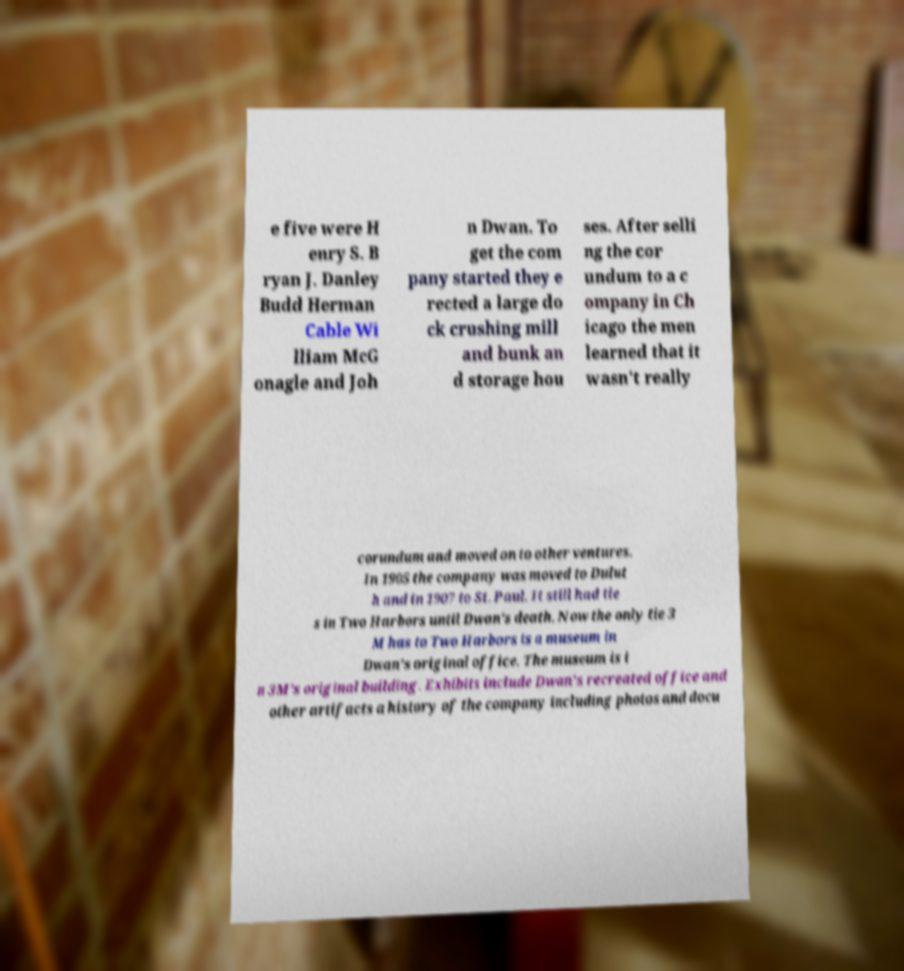Could you extract and type out the text from this image? e five were H enry S. B ryan J. Danley Budd Herman Cable Wi lliam McG onagle and Joh n Dwan. To get the com pany started they e rected a large do ck crushing mill and bunk an d storage hou ses. After selli ng the cor undum to a c ompany in Ch icago the men learned that it wasn't really corundum and moved on to other ventures. In 1905 the company was moved to Dulut h and in 1907 to St. Paul. It still had tie s in Two Harbors until Dwan's death. Now the only tie 3 M has to Two Harbors is a museum in Dwan's original office. The museum is i n 3M's original building. Exhibits include Dwan's recreated office and other artifacts a history of the company including photos and docu 